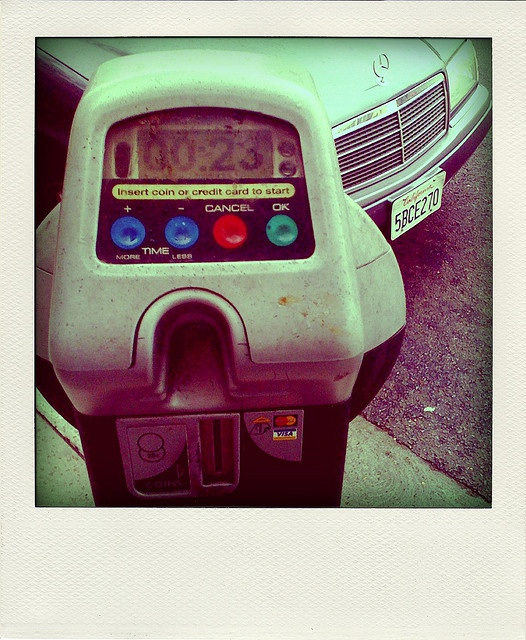Describe the objects in this image and their specific colors. I can see parking meter in lightgray, purple, darkgray, black, and lightgreen tones and car in lightgray, black, lightgreen, aquamarine, and darkgray tones in this image. 